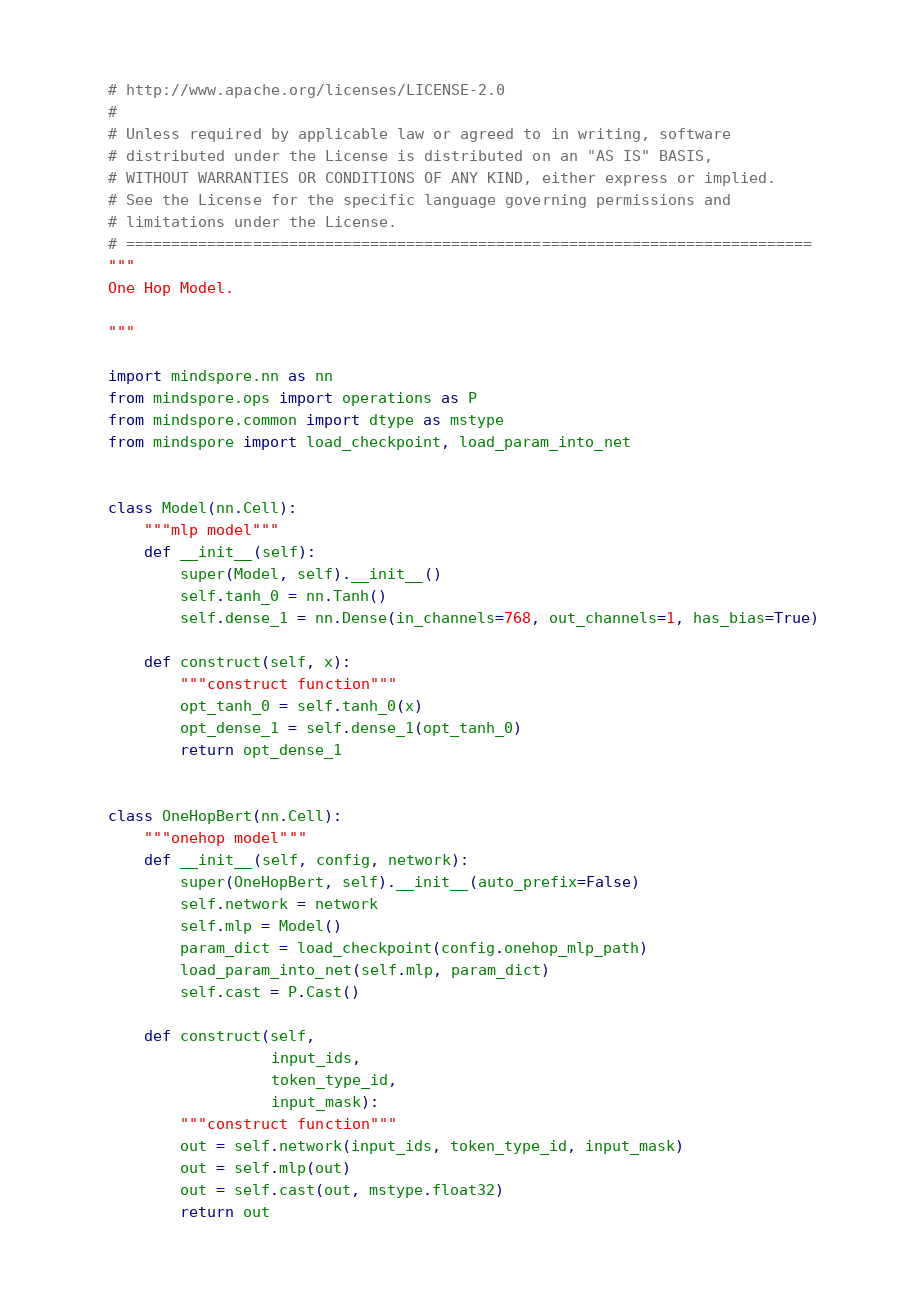Convert code to text. <code><loc_0><loc_0><loc_500><loc_500><_Python_># http://www.apache.org/licenses/LICENSE-2.0
#
# Unless required by applicable law or agreed to in writing, software
# distributed under the License is distributed on an "AS IS" BASIS,
# WITHOUT WARRANTIES OR CONDITIONS OF ANY KIND, either express or implied.
# See the License for the specific language governing permissions and
# limitations under the License.
# ============================================================================
"""
One Hop Model.

"""

import mindspore.nn as nn
from mindspore.ops import operations as P
from mindspore.common import dtype as mstype
from mindspore import load_checkpoint, load_param_into_net


class Model(nn.Cell):
    """mlp model"""
    def __init__(self):
        super(Model, self).__init__()
        self.tanh_0 = nn.Tanh()
        self.dense_1 = nn.Dense(in_channels=768, out_channels=1, has_bias=True)

    def construct(self, x):
        """construct function"""
        opt_tanh_0 = self.tanh_0(x)
        opt_dense_1 = self.dense_1(opt_tanh_0)
        return opt_dense_1


class OneHopBert(nn.Cell):
    """onehop model"""
    def __init__(self, config, network):
        super(OneHopBert, self).__init__(auto_prefix=False)
        self.network = network
        self.mlp = Model()
        param_dict = load_checkpoint(config.onehop_mlp_path)
        load_param_into_net(self.mlp, param_dict)
        self.cast = P.Cast()

    def construct(self,
                  input_ids,
                  token_type_id,
                  input_mask):
        """construct function"""
        out = self.network(input_ids, token_type_id, input_mask)
        out = self.mlp(out)
        out = self.cast(out, mstype.float32)
        return out
</code> 